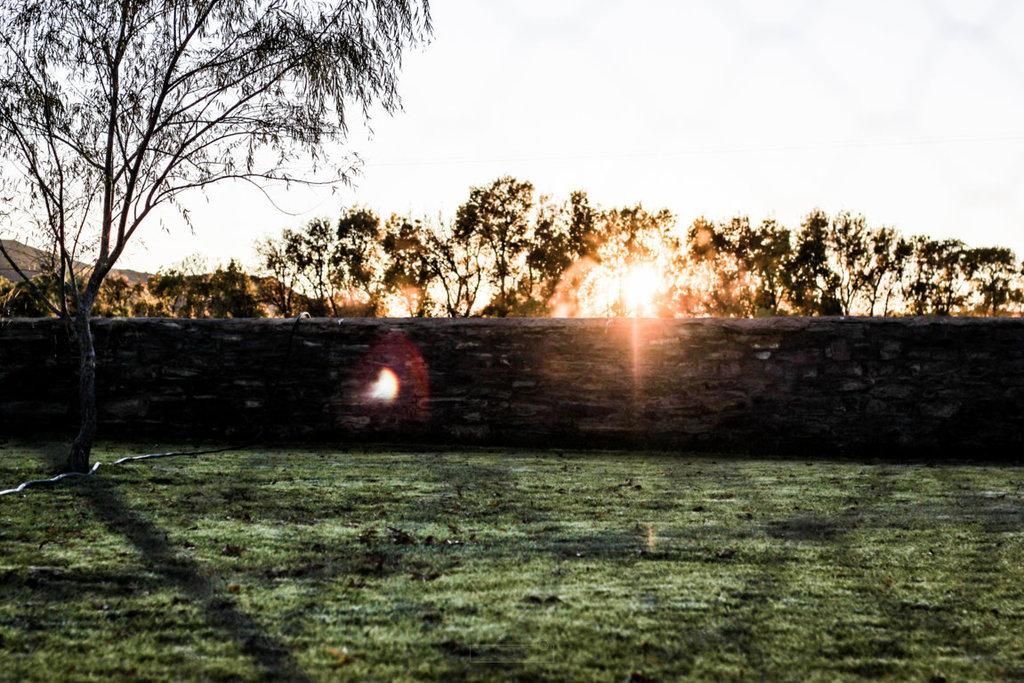What type of vegetation can be seen in the image? There are trees in the image. What type of ground cover is present at the bottom of the image? There is grass at the bottom of the image. What type of structure is visible in the image? There is a wall in the image. What can be seen in the distance in the image? There are hills visible in the background of the image. What is visible above the trees and hills in the image? The sky is visible in the background of the image. How many buckets of water are being carried by the tramp in the image? There is no tramp or bucket of water present in the image. What is the mass of the object that is not visible in the image? It is impossible to determine the mass of an object that is not visible in the image. 